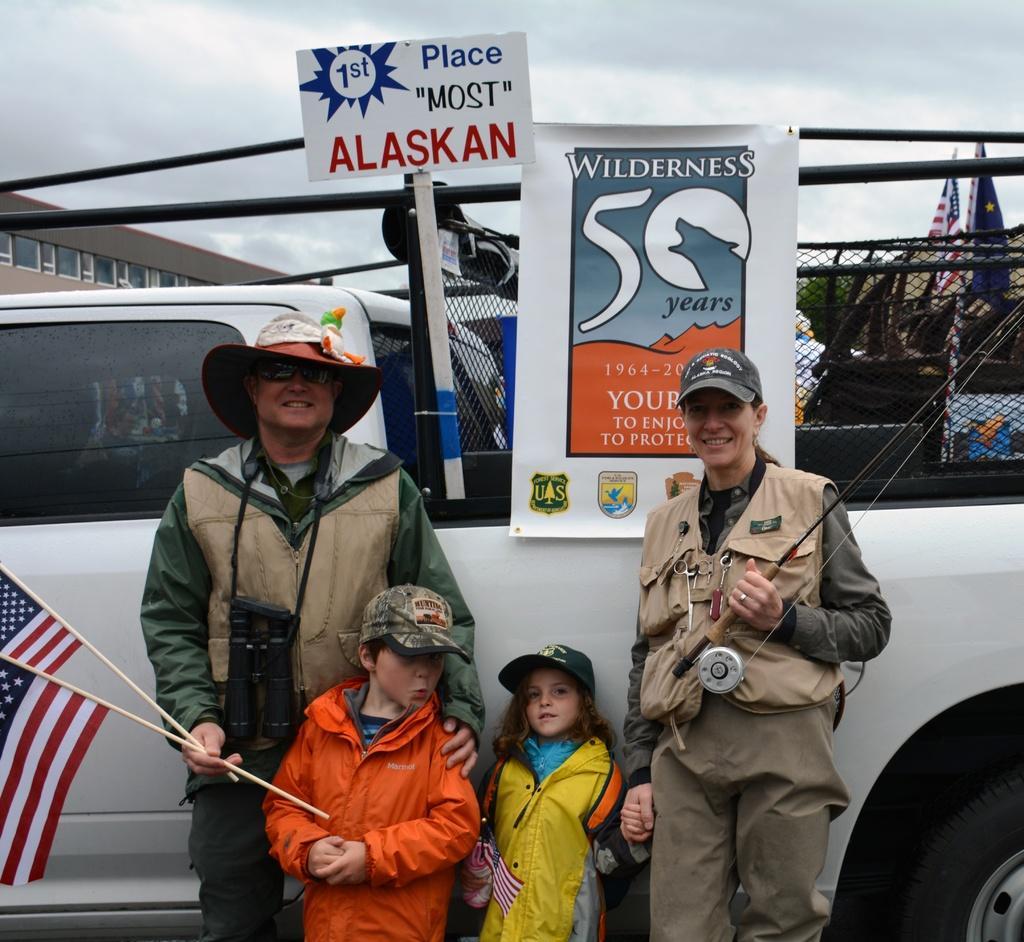Please provide a concise description of this image. In this image we can see one building, some trees, some objects are on the surface, some flags, one vehicle, some posters attached to the vehicle, two persons standing and holding some objects. Two children are standing, one girl holding a small flag and at the top there is the sky. 